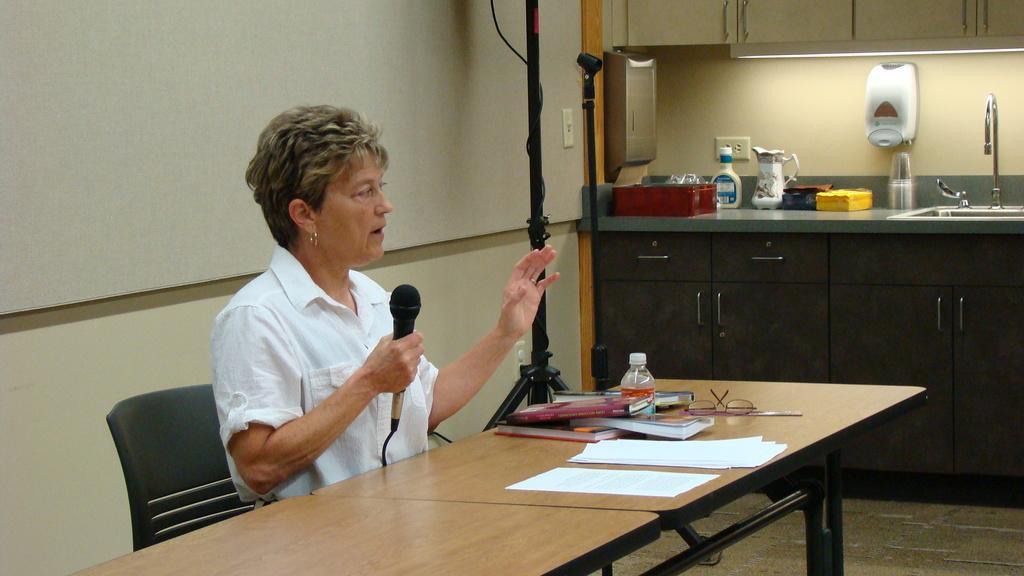Please provide a concise description of this image. in this picture we can see a woman is sitting on a chair and holding a microphone in her hand, and in front there are books bottle, glasses and other objects on the table, and at side there is stand on the floor, and at back there is wall, and at opposite at top there is light. 